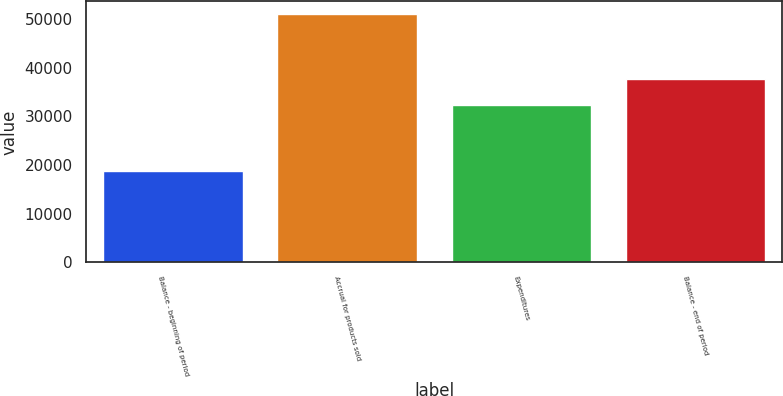Convert chart. <chart><loc_0><loc_0><loc_500><loc_500><bar_chart><fcel>Balance - beginning of period<fcel>Accrual for products sold<fcel>Expenditures<fcel>Balance - end of period<nl><fcel>18817<fcel>51080<fcel>32258<fcel>37639<nl></chart> 